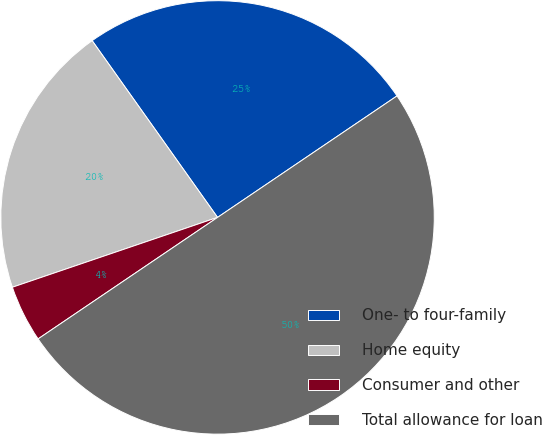<chart> <loc_0><loc_0><loc_500><loc_500><pie_chart><fcel>One- to four-family<fcel>Home equity<fcel>Consumer and other<fcel>Total allowance for loan<nl><fcel>25.35%<fcel>20.4%<fcel>4.25%<fcel>50.0%<nl></chart> 